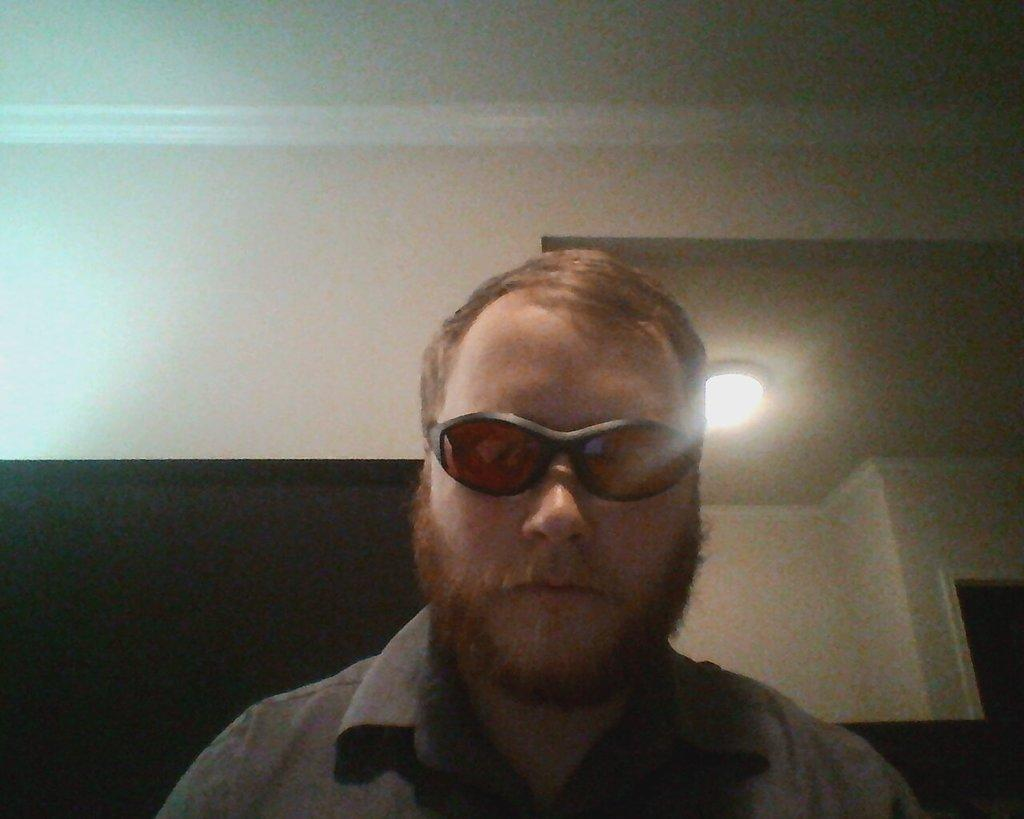Who is present in the image? There is a man in the image. What is the man wearing on his face? The man is wearing goggles. What can be seen behind the man? There is a wall and a light behind the man. Can you describe the black object in the bottom left of the image? There is a black object in the bottom left of the image. How many legs does the quiver have in the image? There is no quiver present in the image, so it is not possible to determine how many legs it might have. 